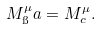<formula> <loc_0><loc_0><loc_500><loc_500>M ^ { \mu } _ { \i } a = M ^ { \mu } _ { c } .</formula> 